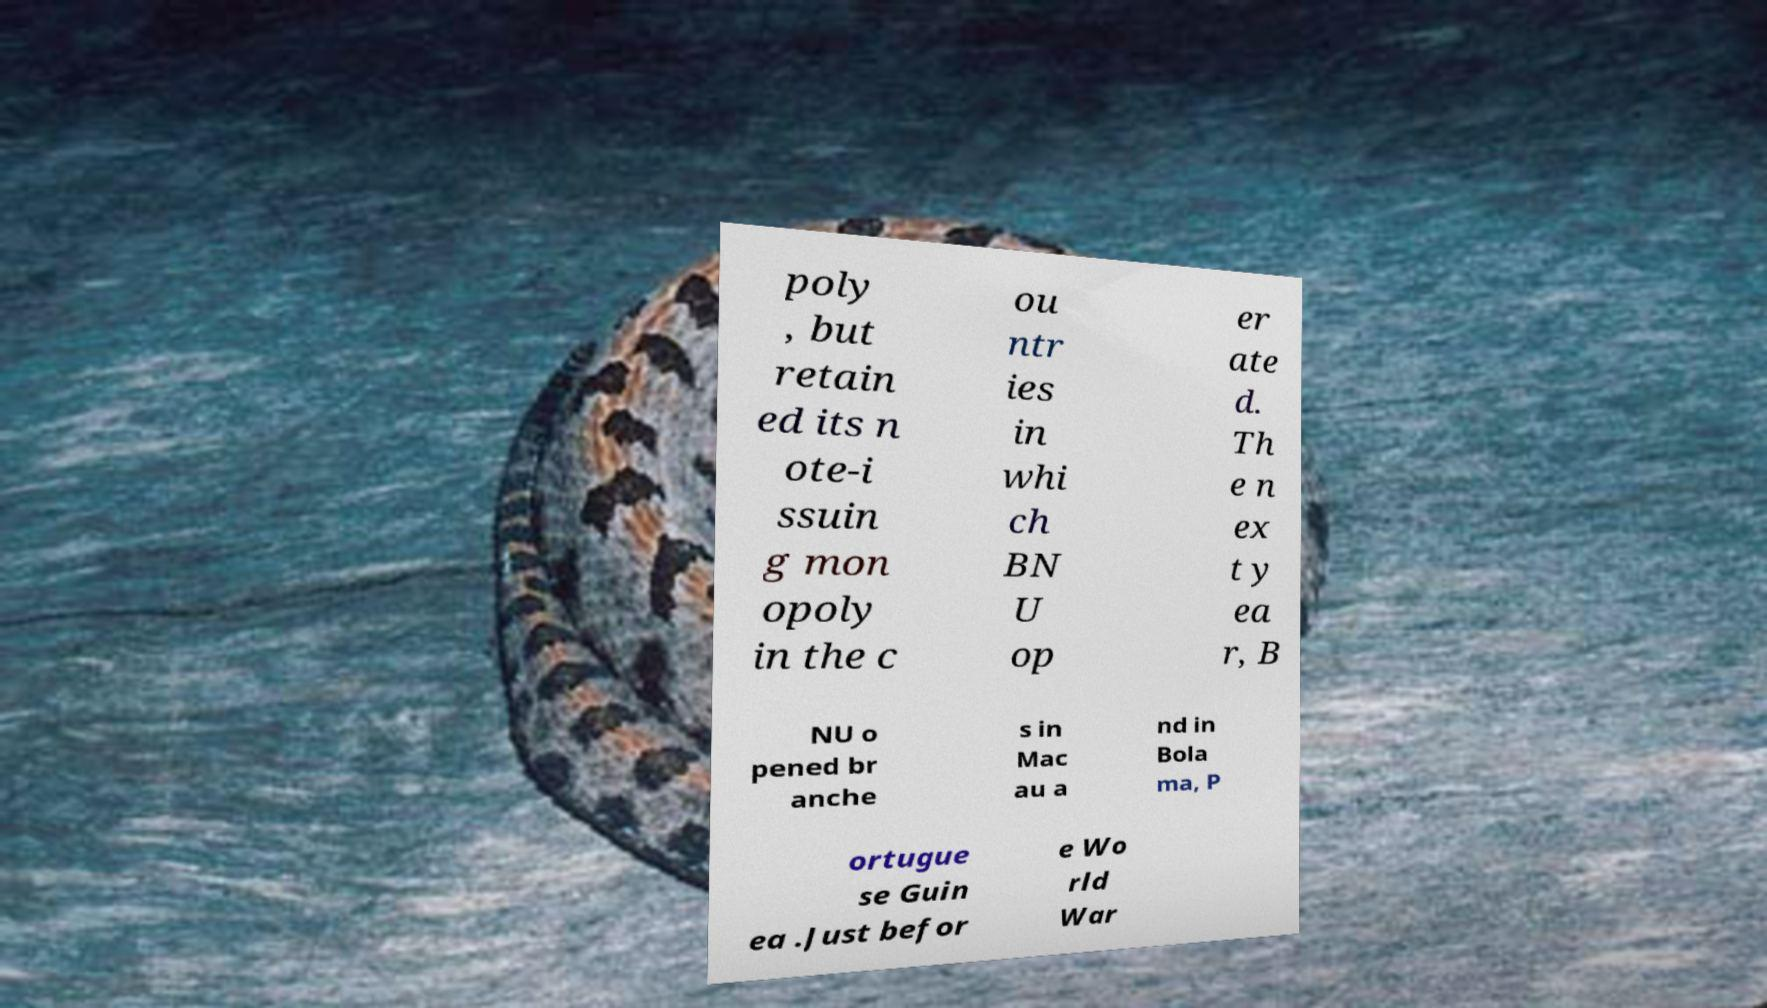For documentation purposes, I need the text within this image transcribed. Could you provide that? poly , but retain ed its n ote-i ssuin g mon opoly in the c ou ntr ies in whi ch BN U op er ate d. Th e n ex t y ea r, B NU o pened br anche s in Mac au a nd in Bola ma, P ortugue se Guin ea .Just befor e Wo rld War 